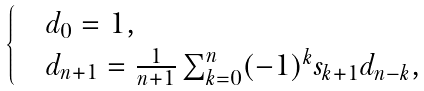Convert formula to latex. <formula><loc_0><loc_0><loc_500><loc_500>\begin{cases} & d _ { 0 } = 1 , \\ & d _ { n + 1 } = \frac { 1 } { n + 1 } \sum _ { k = 0 } ^ { n } ( - 1 ) ^ { k } s _ { k + 1 } d _ { n - k } , \end{cases}</formula> 